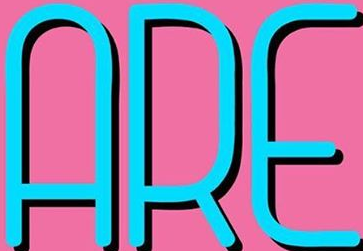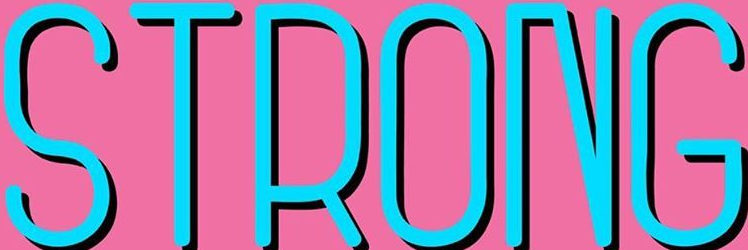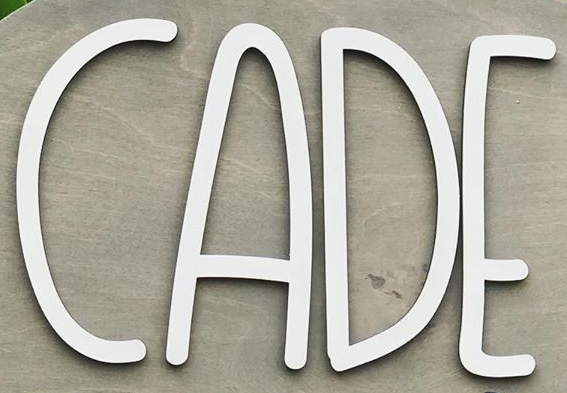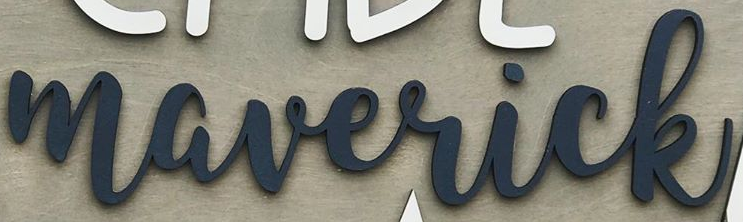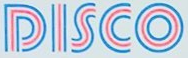Transcribe the words shown in these images in order, separated by a semicolon. ARE; STRONG; ACDE; maverick; DISCO 